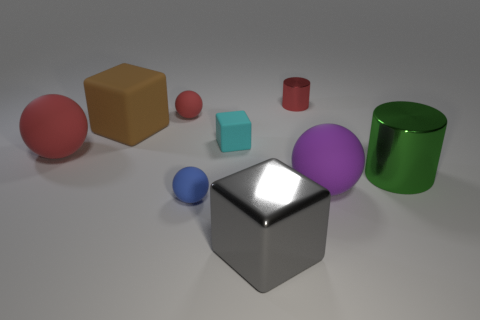Subtract all cylinders. How many objects are left? 7 Add 6 small blocks. How many small blocks exist? 7 Subtract 0 gray spheres. How many objects are left? 9 Subtract all tiny green shiny objects. Subtract all big red spheres. How many objects are left? 8 Add 1 small matte cubes. How many small matte cubes are left? 2 